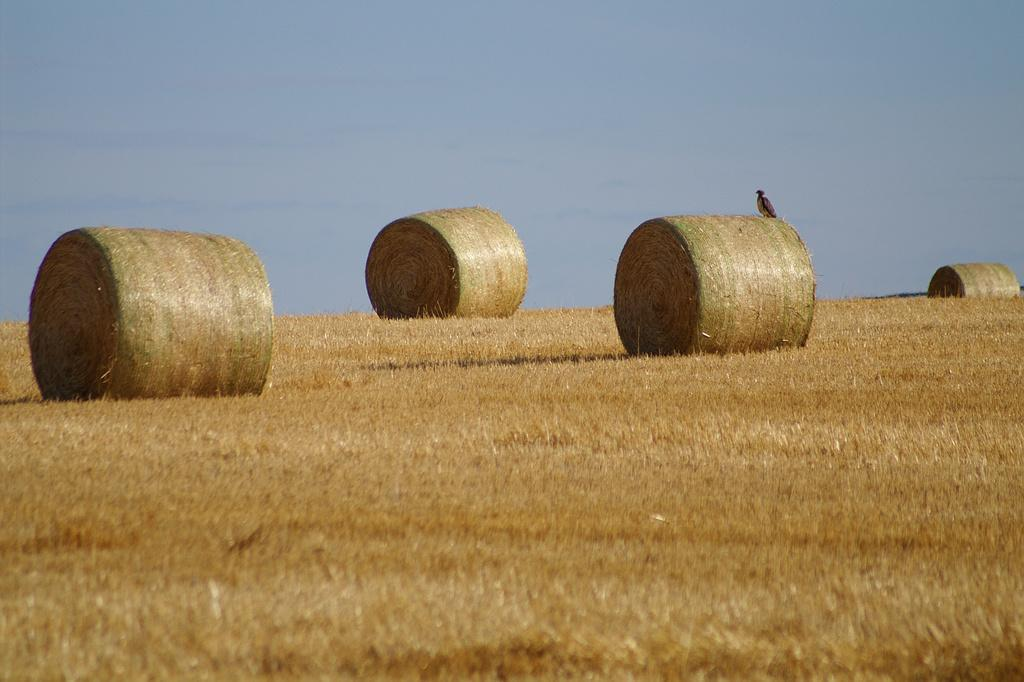What type of vegetation is present in the image? There is dry grass in the image. What else can be seen in the image besides the dry grass? There is hay in the image. Is there any wildlife visible in the image? Yes, there is a bird on the dry grass. What is the color of the sky in the background of the image? The sky in the background is pale blue. How much eggnog is being consumed by the bird in the image? There is no eggnog present in the image, and the bird is not consuming anything. 